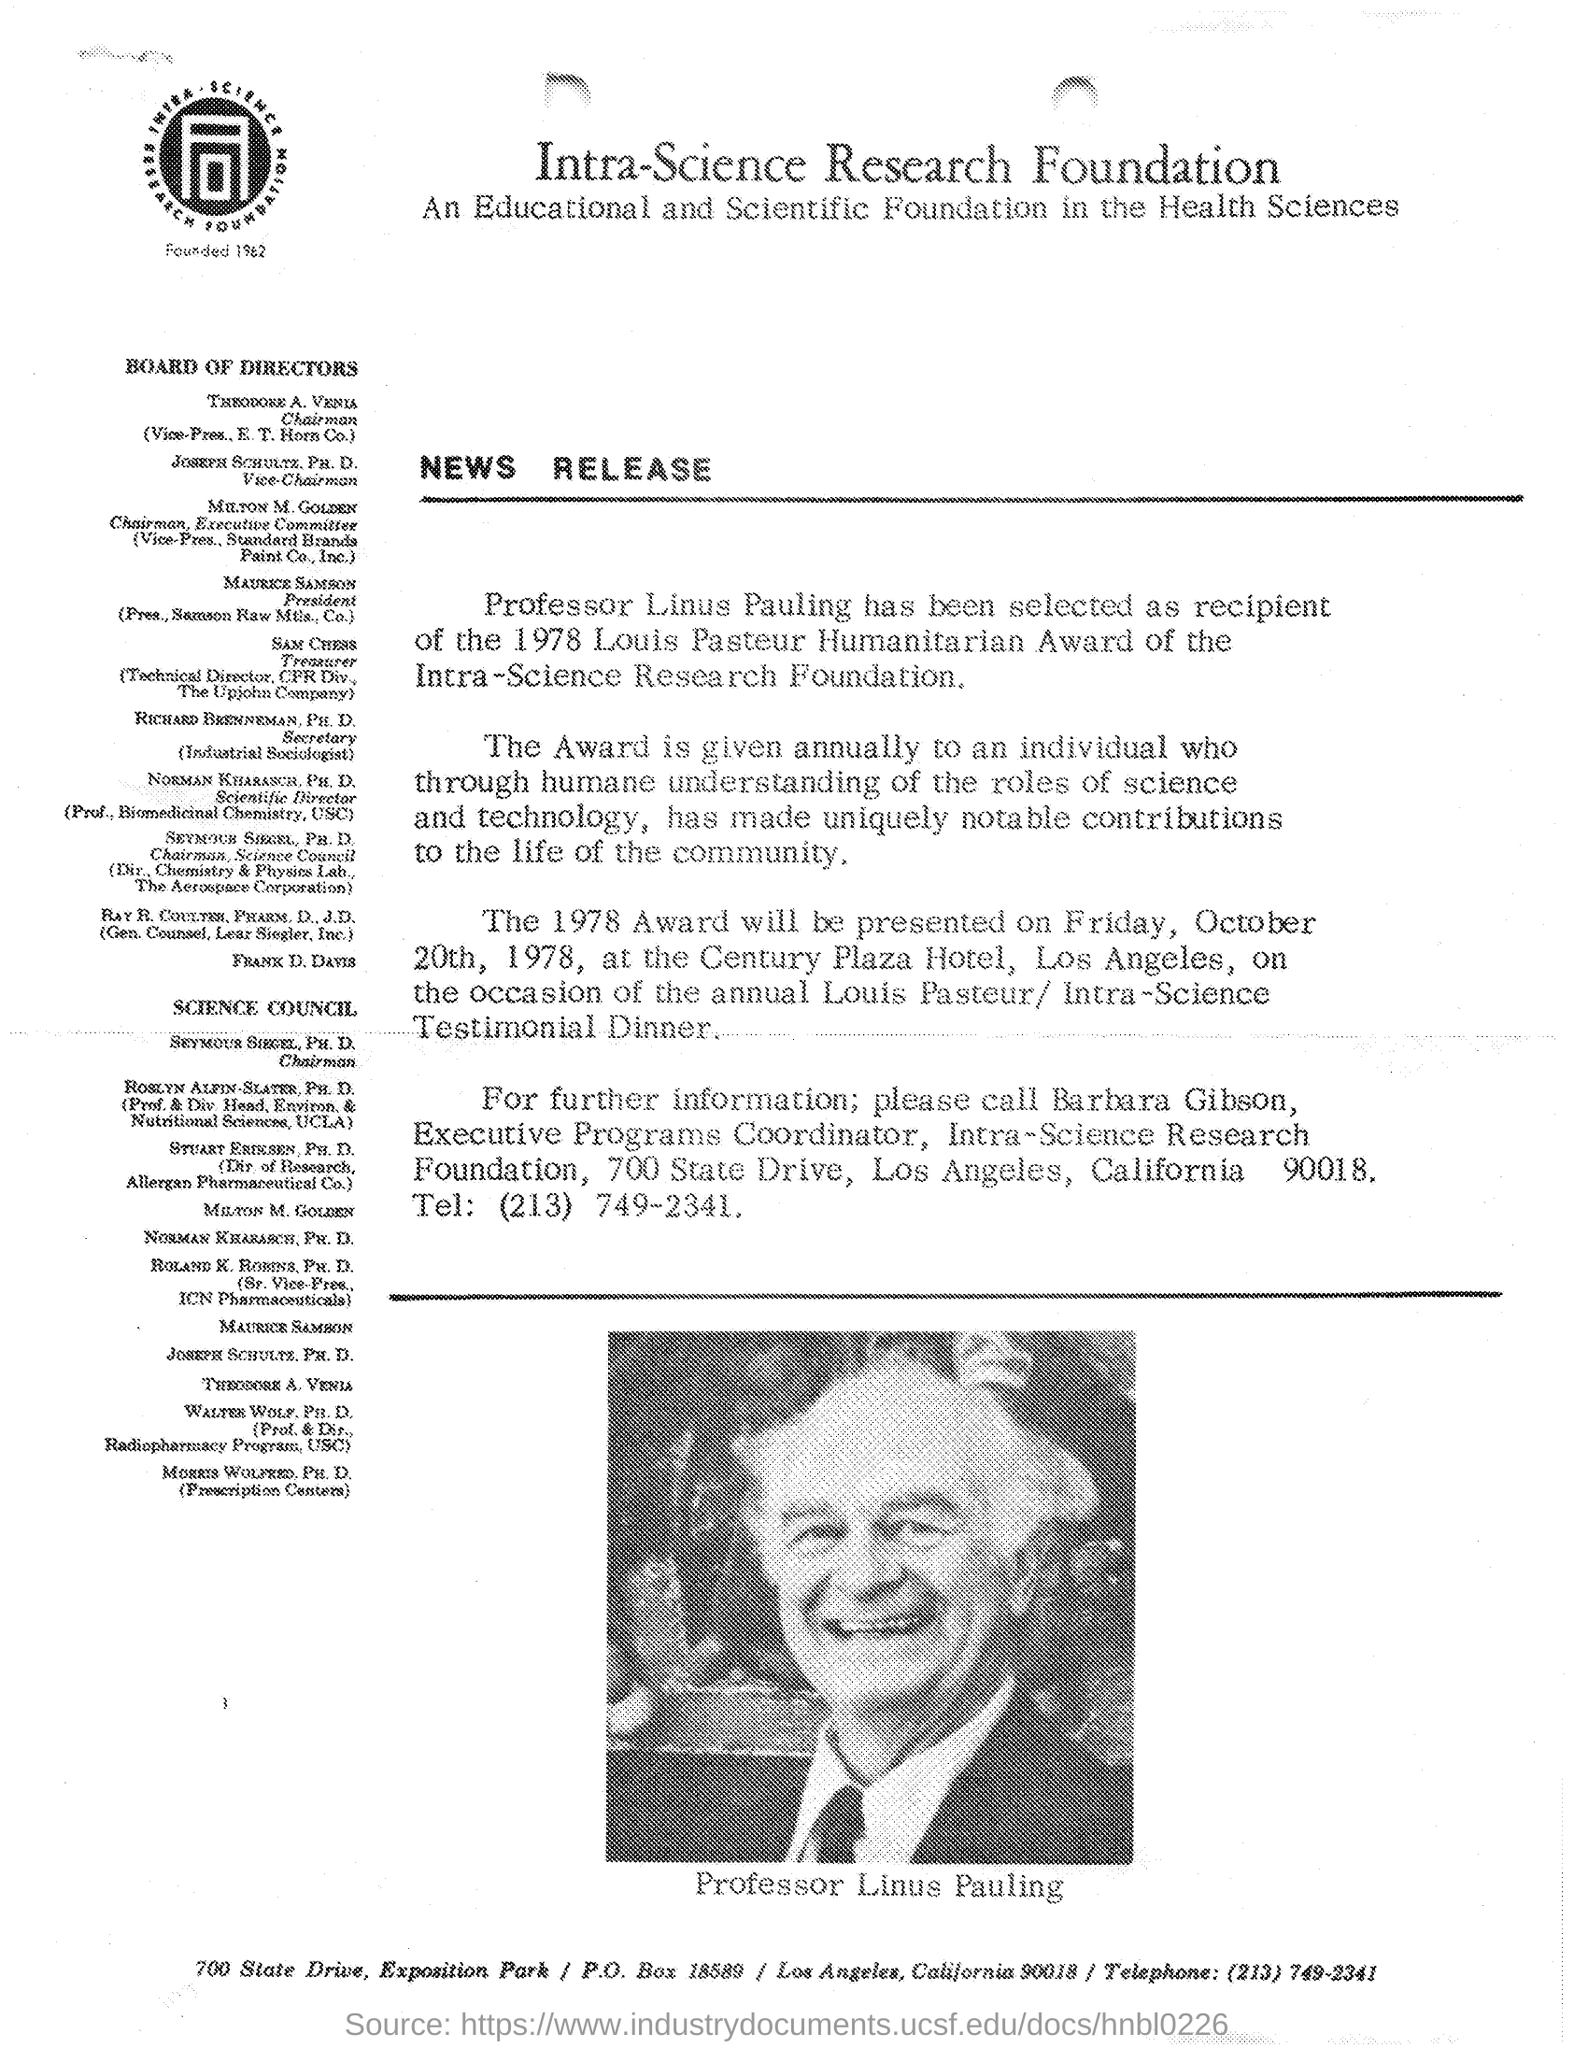List a handful of essential elements in this visual. The person in the image is named Professor Linus Pauling. 